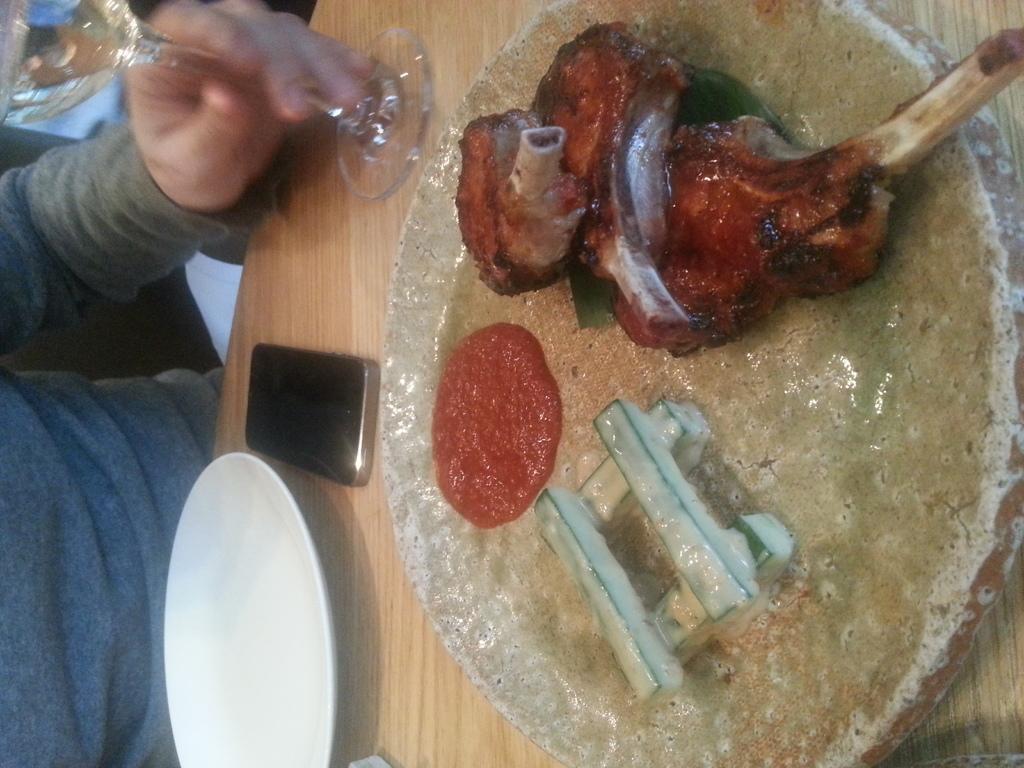How would you summarize this image in a sentence or two? In this image there is a table towards the right of the image, there is a bowl on the table, there is food in the bowl, there is a glass on the table, there is a mobile phone on the table, there is a plate on the table, there is a person towards the left of the image, there are objects towards the left of the image. 